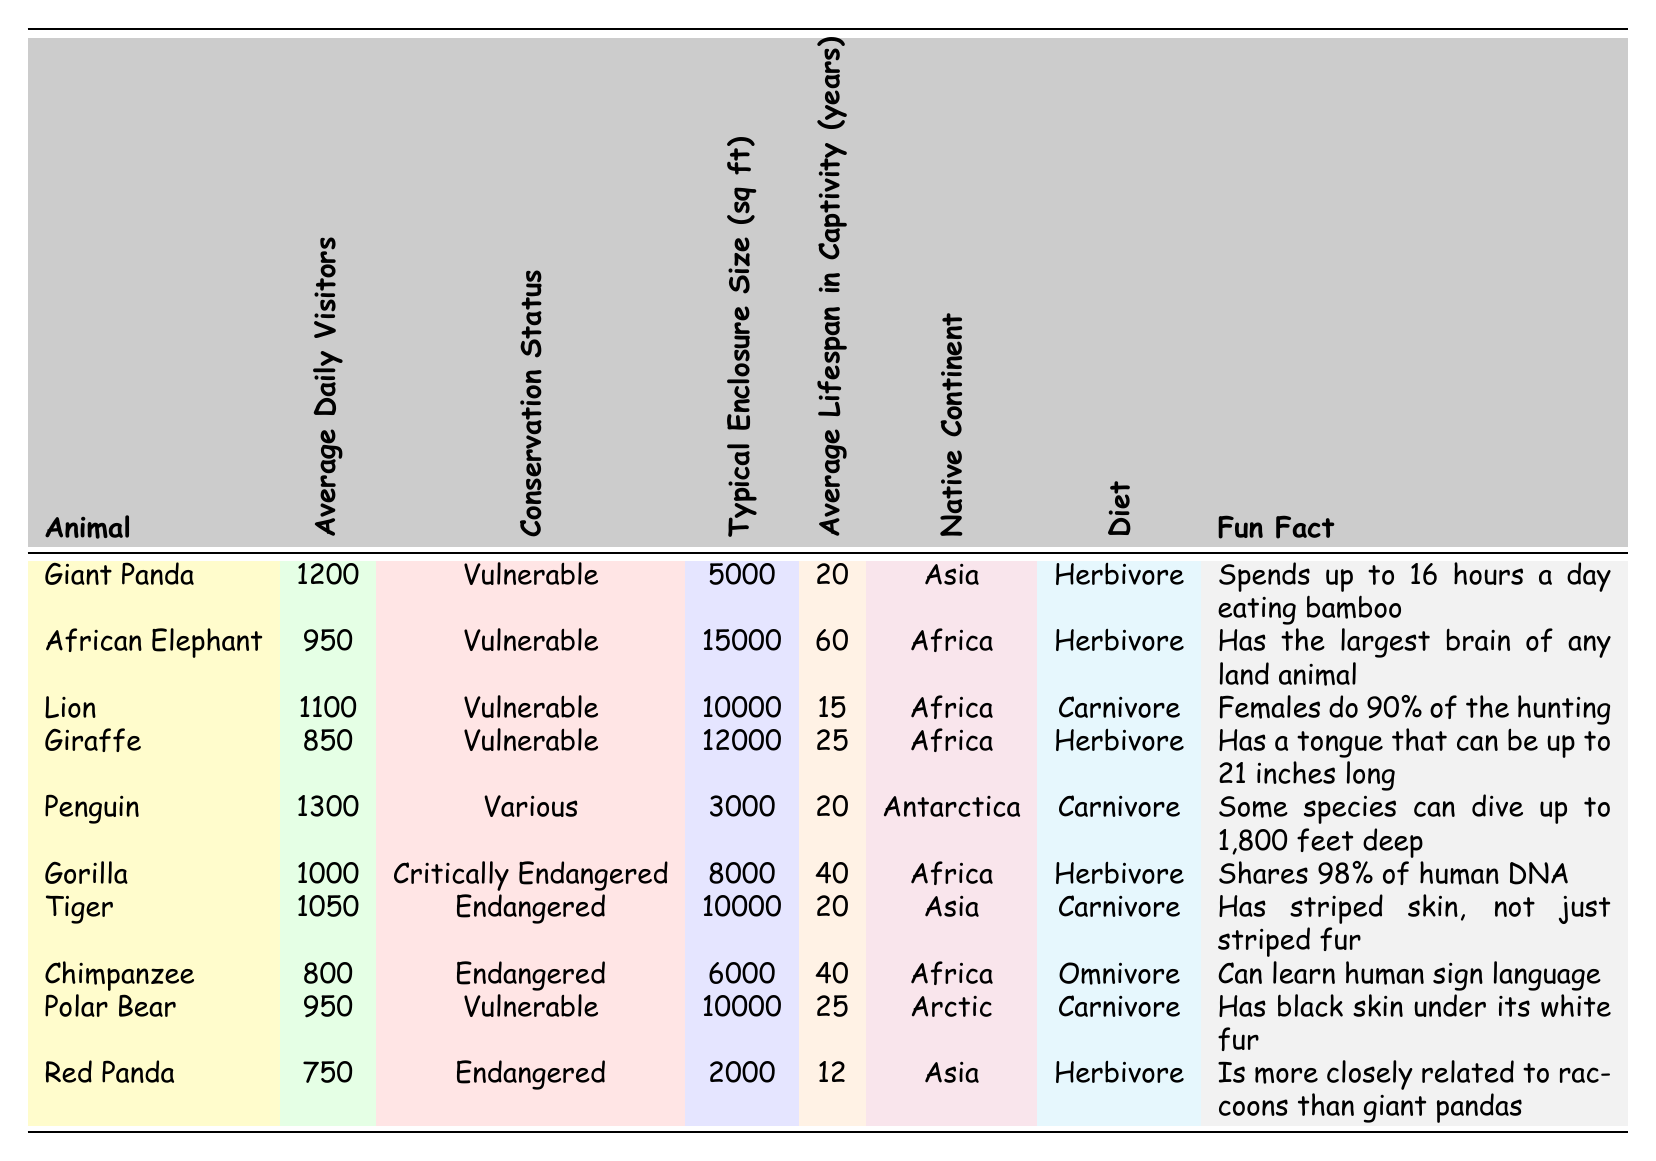What animal has the highest average daily visitors? The table shows that the Penguin has the highest average daily visitors, with 1300 reported in the data.
Answer: Penguin What is the typical enclosure size for an African Elephant? Referring to the table, the typical enclosure size for an African Elephant is 15,000 square feet.
Answer: 15,000 sq ft How many years does a Red Panda typically live in captivity? According to the table, a Red Panda typically lives 12 years in captivity.
Answer: 12 years Is the Lion's conservation status categorized as endangered? The table shows that the Lion's conservation status is listed as Vulnerable, which is not classified as endangered but is at risk.
Answer: No What is the diet of a Giraffe? In the table, it states that the Giraffe is a herbivore, meaning it primarily eats plants.
Answer: Herbivore Which animal has the longest average lifespan in captivity? By examining the table, the African Elephant has the longest average lifespan of 60 years in captivity.
Answer: African Elephant How many species mentioned are classified as Endangered? There are three animals listed as Endangered: Tiger, Chimpanzee, and Red Panda. Hence, the count is 3.
Answer: 3 Which animal shares 98% of its DNA with humans? The table indicates that the Gorilla shares 98% of its DNA with humans.
Answer: Gorilla Calculate the average daily visitors for all the animals listed. To find the average, we sum the daily visitors (1200 + 950 + 1100 + 850 + 1300 + 1000 + 1050 + 800 + 950 + 750) = 10,900 visitors and then divide by the number of animals, which is 10. Thus, 10,900 / 10 = 1090.
Answer: 1090 Which animal has the smallest typical enclosure size? Looking at the table, the Red Panda has the smallest typical enclosure size of 2000 square feet.
Answer: 2000 sq ft 